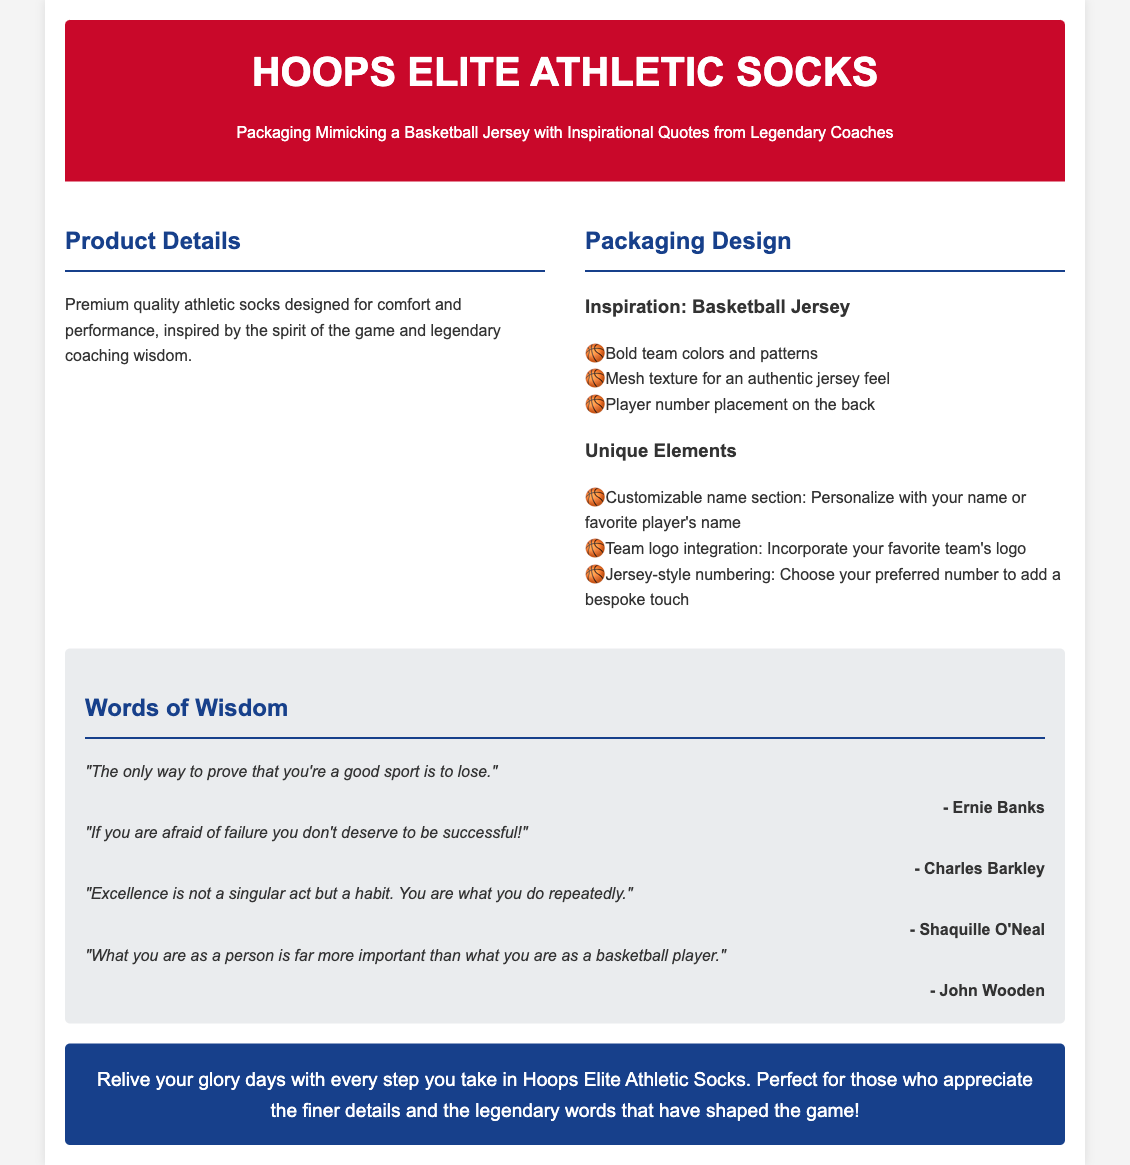what is the product name? The product is named "Hoops Elite Athletic Socks," as stated in the header of the document.
Answer: Hoops Elite Athletic Socks what type of design is the packaging inspired by? The packaging design is inspired by a "Basketball Jersey," which is mentioned in the packaging design section.
Answer: Basketball Jersey who is one of the authors of the quotes? One of the authors of the quotes is "Ernie Banks," which is listed in the quotes section.
Answer: Ernie Banks what is the customizable section in the packaging? The packaging includes a "Customizable name section" allowing personalization with names or players' names.
Answer: Customizable name section how many inspirational quotes are provided in the document? There are four inspirational quotes listed in the quotes section of the document.
Answer: Four what does the color scheme of the packaging focus on? The color scheme of the packaging focuses on "Bold team colors and patterns," as mentioned in the packaging design details.
Answer: Bold team colors and patterns what does the call-to-action encourage? The call-to-action encourages readers to "Relive your glory days" while wearing the socks, suggesting an emotional connection to basketball.
Answer: Relive your glory days which legendary coach quote emphasizes excellence? The quote by "Shaquille O'Neal" emphasizes that "Excellence is not a singular act but a habit."
Answer: Shaquille O'Neal 